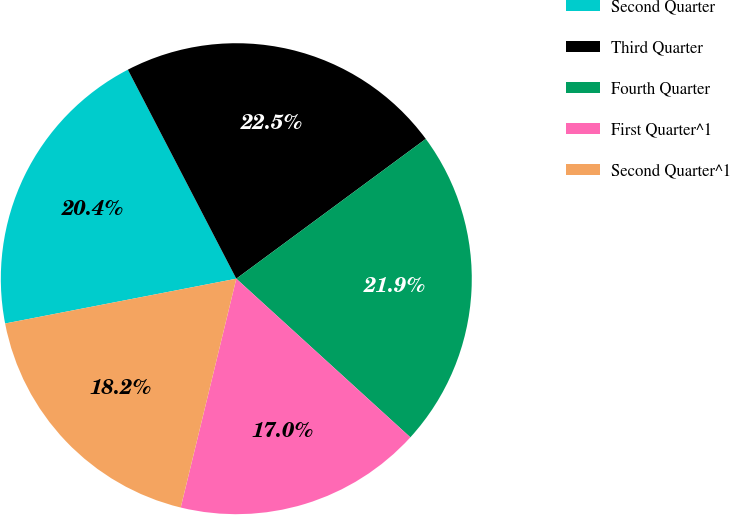Convert chart to OTSL. <chart><loc_0><loc_0><loc_500><loc_500><pie_chart><fcel>Second Quarter<fcel>Third Quarter<fcel>Fourth Quarter<fcel>First Quarter^1<fcel>Second Quarter^1<nl><fcel>20.43%<fcel>22.5%<fcel>21.88%<fcel>17.03%<fcel>18.16%<nl></chart> 